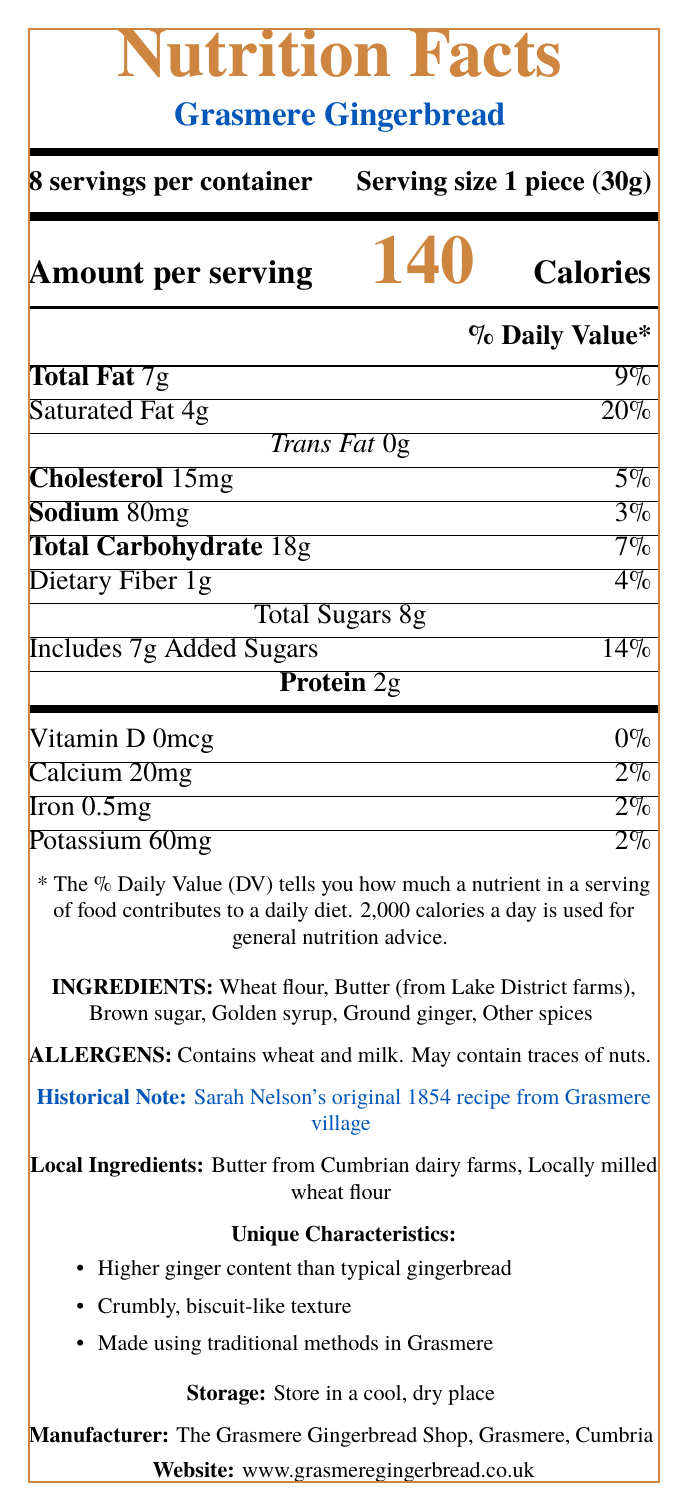what is the serving size for Grasmere Gingerbread? The serving size is clearly listed in the document as "1 piece (30g)."
Answer: 1 piece (30g) how many calories are in one serving of Grasmere Gingerbread? The document states that there are 140 calories per serving.
Answer: 140 what historical recipe is used for Grasmere Gingerbread? The document mentions that the gingerbread is made using Sarah Nelson's original recipe from 1854.
Answer: Sarah Nelson's original 1854 recipe from Grasmere village what is the total carbohydrate content per serving? According to the document, the total carbohydrate content per serving is 18g.
Answer: 18g what allergens are present in Grasmere Gingerbread? The document lists the allergens as wheat and milk and mentions that it may contain traces of nuts.
Answer: Contains wheat and milk; May contain traces of nuts which ingredient is locally sourced from the Lake District farms? A. Brown sugar B. Butter C. Golden syrup D. Ground ginger The butter is mentioned as being from Lake District farms.
Answer: B. Butter what percentage of the daily value for saturated fat does one serving contain? The document lists that one serving contains 20% of the daily value for saturated fat.
Answer: 20% does Grasmere Gingerbread contain any trans fat? The document explicitly states that it contains 0g of trans fat.
Answer: No how should Grasmere Gingerbread be stored? The storage instructions in the document advise storing the product in a cool, dry place.
Answer: Store in a cool, dry place which ingredient is NOT listed in Grasmere Gingerbread? A. Wheat flour B. Raisins C. Butter D. Brown sugar Raisins are not listed in the ingredients; the document mentions wheat flour, butter, and brown sugar among the listed ingredients.
Answer: B. Raisins what are the unique characteristics of Grasmere Gingerbread? These unique characteristics are listed separately in the document under the "Unique Characteristics" section.
Answer: Higher ginger content, Crumbly, biscuit-like texture, Made using traditional methods in Grasmere which of the following minerals is present in the lowest amount per serving? A. Calcium B. Iron C. Potassium D. Sodium The document lists calcium as having 20mg per serving, the smallest amount compared to iron (0.5mg), potassium (60mg), and sodium (80mg).
Answer: A. Calcium what percentage of the daily value does dietary fiber from one serving contribute? The dietary fiber content contributes 4% of the daily value per serving, as listed in the document.
Answer: 4% how many servings are there per container of Grasmere Gingerbread? The document states that there are 8 servings per container.
Answer: 8 servings summarize the document in a few sentences. This summary covers the key points in the document, touching on the nutritional data, ingredients, historical note, unique characteristics, and other essential information.
Answer: The document provides the nutritional facts for Grasmere Gingerbread, including serving size, calories, and % daily values for various nutrients. It lists the ingredients and allergens, mentions that it is made using Sarah Nelson's original 1854 recipe, and highlights its unique characteristics, such as higher ginger content and crumbly texture. The document also includes storage instructions and notes the use of local ingredients. what are the ingredients that might be sourced locally? The document explicitly mentions that butter and wheat flour are sourced locally from Cumbrian farms and mills.
Answer: Butter from Cumbrian dairy farms, Locally milled wheat flour who manufactures Grasmere Gingerbread? The manufacturer is listed as The Grasmere Gingerbread Shop located in Grasmere, Cumbria.
Answer: The Grasmere Gingerbread Shop, Grasmere, Cumbria what is the website for more information about Grasmere Gingerbread? The document provides the website for further information at the bottom.
Answer: www.grasmeregingerbread.co.uk what is the exact amount of protein per serving? The document states that there are 2g of protein per serving.
Answer: 2g which local farm product is used as an ingredient? The document mentions butter as being sourced from Cumbrian dairy farms.
Answer: Butter from Cumbrian dairy farms what is the total protein content per container? There are 2g of protein per serving and 8 servings per container, so 2g x 8 = 16g of protein per container.
Answer: 16g does the document mention any dietary fibers contained in the product? The document lists 1g of dietary fiber per serving.
Answer: Yes which village is associated with the historical recipe for the gingerbread? The historical note mentions that the recipe originates from Grasmere village.
Answer: Grasmere village how many grams of added sugars are in one serving? The document lists that there are 7g of added sugars per serving.
Answer: 7g which nutrient contributes the least to the daily value? The document shows that Vitamin D contributes 0% of the daily value.
Answer: Vitamin D (0%) does the Grasmere Gingerbread contain higher ginger content than typical gingerbread? In the unique characteristics section, the document mentions that it has higher ginger content than typical gingerbread.
Answer: Yes can you determine the price of Grasmere Gingerbread from the document? The document does not provide any information about the price of the product.
Answer: Cannot be determined 